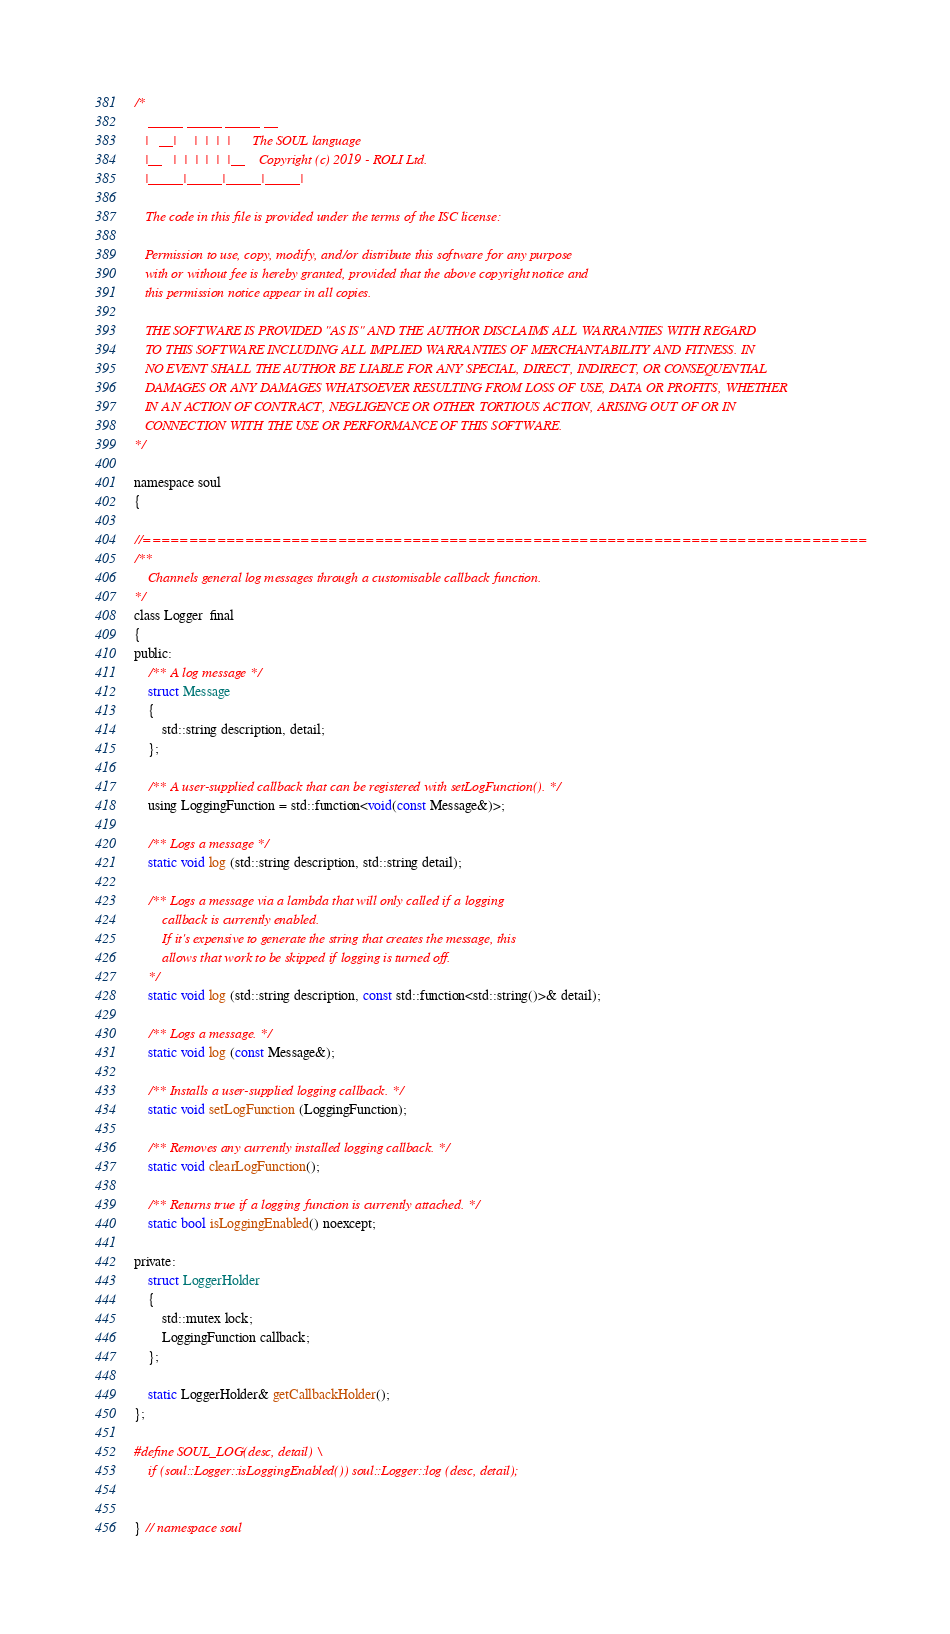<code> <loc_0><loc_0><loc_500><loc_500><_C_>/*
    _____ _____ _____ __
   |   __|     |  |  |  |      The SOUL language
   |__   |  |  |  |  |  |__    Copyright (c) 2019 - ROLI Ltd.
   |_____|_____|_____|_____|

   The code in this file is provided under the terms of the ISC license:

   Permission to use, copy, modify, and/or distribute this software for any purpose
   with or without fee is hereby granted, provided that the above copyright notice and
   this permission notice appear in all copies.

   THE SOFTWARE IS PROVIDED "AS IS" AND THE AUTHOR DISCLAIMS ALL WARRANTIES WITH REGARD
   TO THIS SOFTWARE INCLUDING ALL IMPLIED WARRANTIES OF MERCHANTABILITY AND FITNESS. IN
   NO EVENT SHALL THE AUTHOR BE LIABLE FOR ANY SPECIAL, DIRECT, INDIRECT, OR CONSEQUENTIAL
   DAMAGES OR ANY DAMAGES WHATSOEVER RESULTING FROM LOSS OF USE, DATA OR PROFITS, WHETHER
   IN AN ACTION OF CONTRACT, NEGLIGENCE OR OTHER TORTIOUS ACTION, ARISING OUT OF OR IN
   CONNECTION WITH THE USE OR PERFORMANCE OF THIS SOFTWARE.
*/

namespace soul
{

//==============================================================================
/**
    Channels general log messages through a customisable callback function.
*/
class Logger  final
{
public:
    /** A log message */
    struct Message
    {
        std::string description, detail;
    };

    /** A user-supplied callback that can be registered with setLogFunction(). */
    using LoggingFunction = std::function<void(const Message&)>;

    /** Logs a message */
    static void log (std::string description, std::string detail);

    /** Logs a message via a lambda that will only called if a logging
        callback is currently enabled.
        If it's expensive to generate the string that creates the message, this
        allows that work to be skipped if logging is turned off.
    */
    static void log (std::string description, const std::function<std::string()>& detail);

    /** Logs a message. */
    static void log (const Message&);

    /** Installs a user-supplied logging callback. */
    static void setLogFunction (LoggingFunction);

    /** Removes any currently installed logging callback. */
    static void clearLogFunction();

    /** Returns true if a logging function is currently attached. */
    static bool isLoggingEnabled() noexcept;

private:
    struct LoggerHolder
    {
        std::mutex lock;
        LoggingFunction callback;
    };

    static LoggerHolder& getCallbackHolder();
};

#define SOUL_LOG(desc, detail) \
    if (soul::Logger::isLoggingEnabled()) soul::Logger::log (desc, detail);


} // namespace soul
</code> 